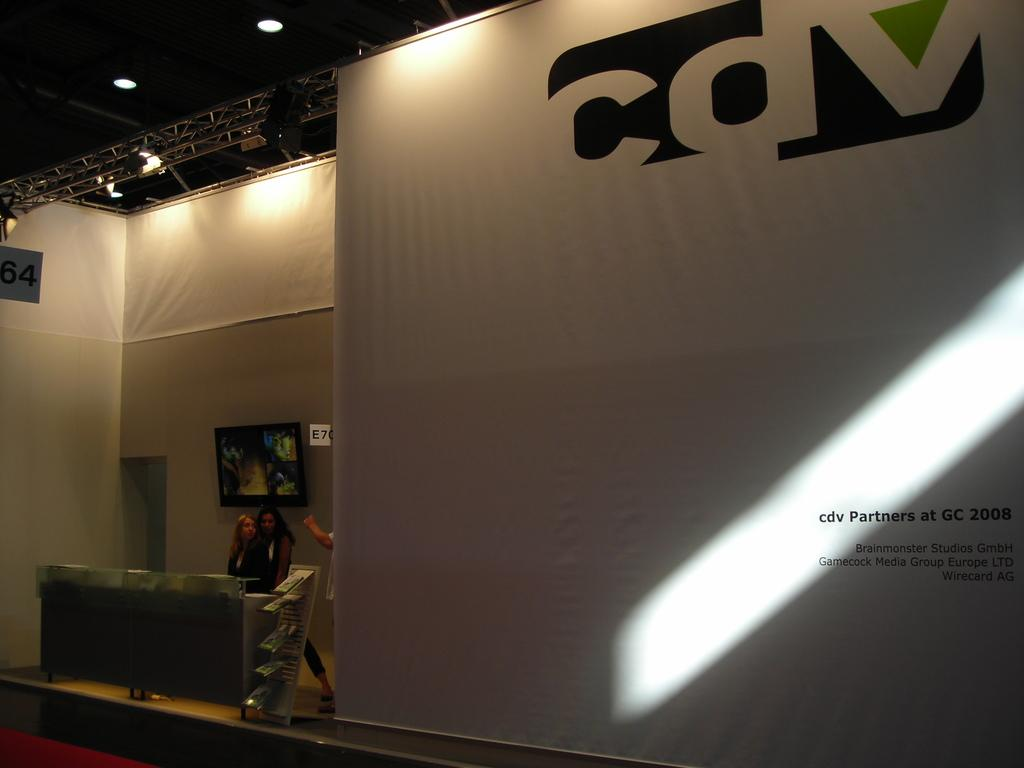<image>
Offer a succinct explanation of the picture presented. The letter C can be seen on a large white wall. 